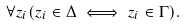<formula> <loc_0><loc_0><loc_500><loc_500>\forall z _ { i } ( z _ { i } \in \Delta \iff z _ { i } \in \Gamma ) .</formula> 